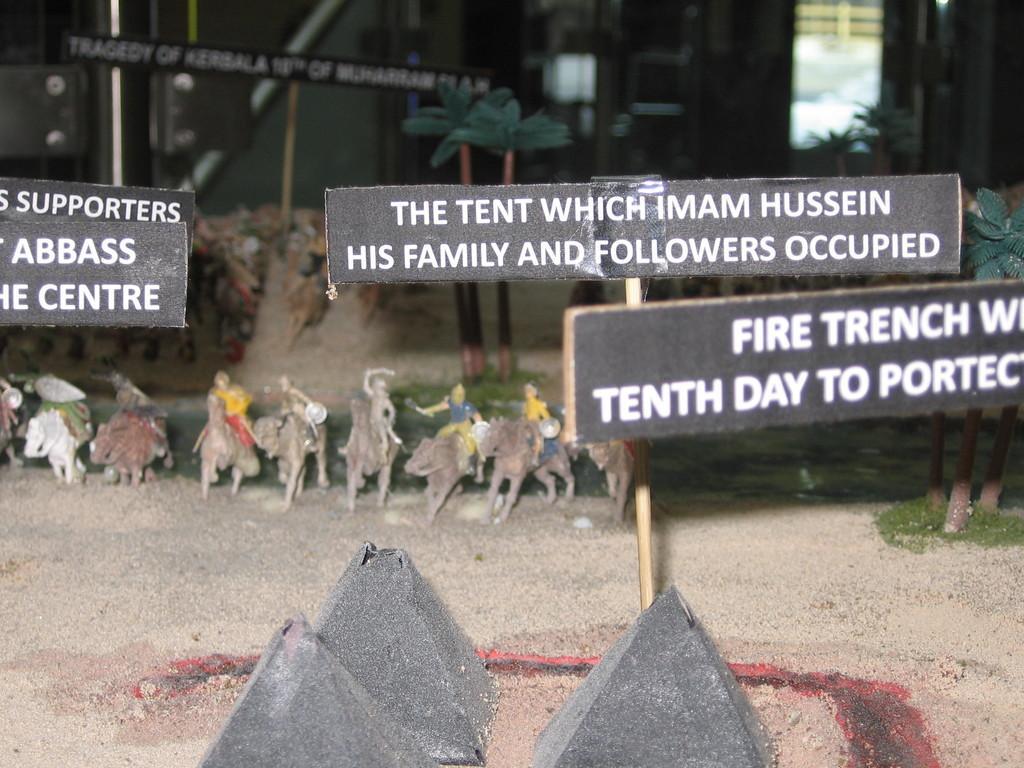Could you give a brief overview of what you see in this image? In this picture we can see boards, toys, trees, pyramids, soil, grass, door, wall are present. 